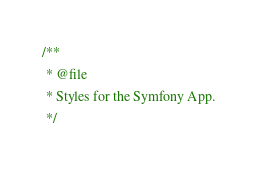<code> <loc_0><loc_0><loc_500><loc_500><_CSS_>/**
 * @file
 * Styles for the Symfony App.
 */
</code> 